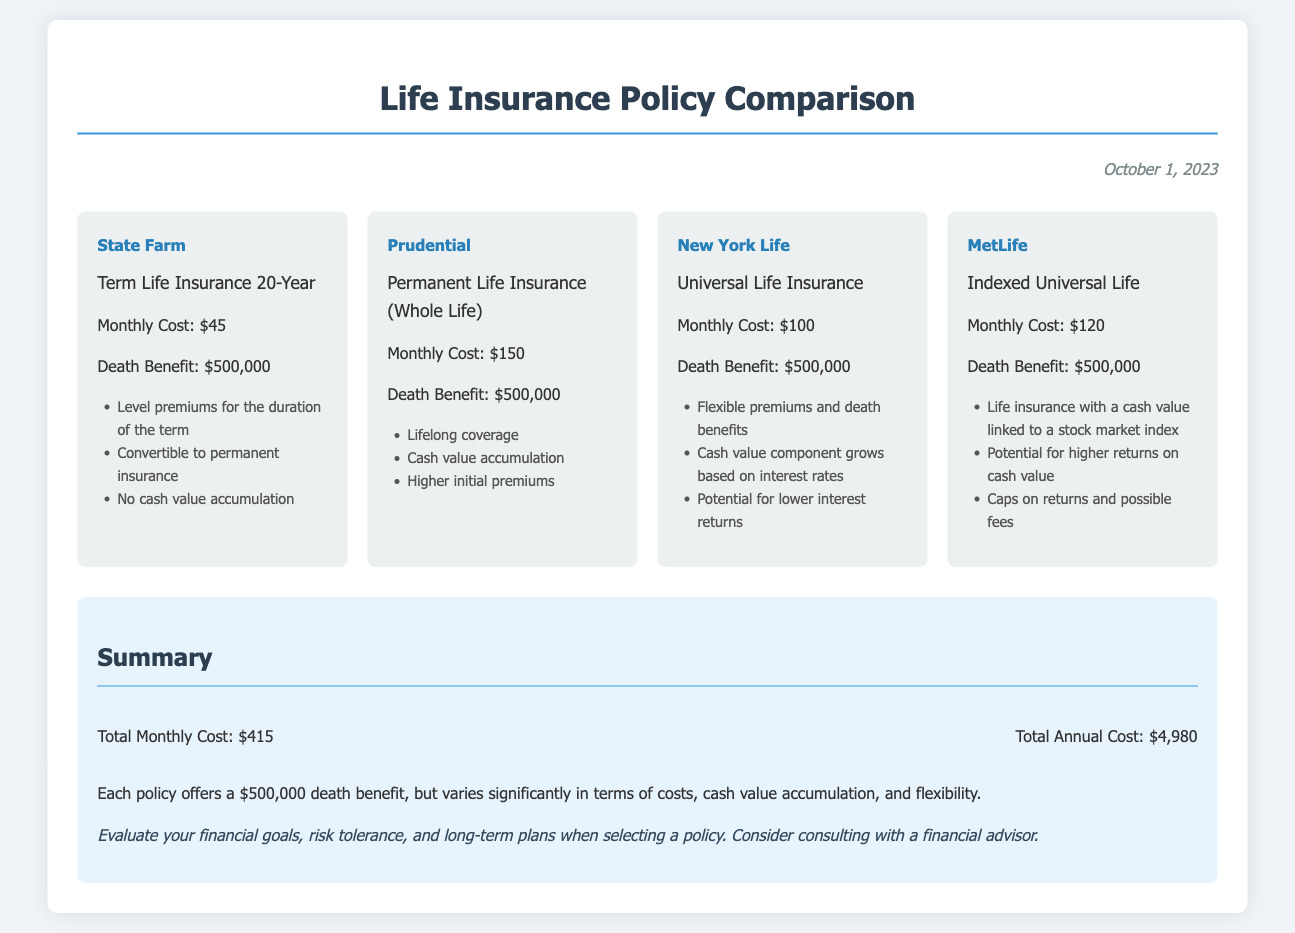What is the monthly cost for State Farm's policy? The monthly cost for State Farm's Term Life Insurance 20-Year policy is provided in the document, which is $45.
Answer: $45 What is the death benefit offered by Prudential? The document states that Prudential's policy offers a death benefit of $500,000.
Answer: $500,000 Which policy has the highest monthly cost? To determine the policy with the highest monthly cost, we compare the monthly costs provided in the document; Prudential has the highest at $150.
Answer: $150 What type of policy does New York Life offer? The document indicates that New York Life offers a Universal Life Insurance policy.
Answer: Universal Life Insurance What is the total annual cost for all policies? The document calculates the total annual cost by multiplying the total monthly cost of $415 by 12 months, leading to an annual total of $4,980.
Answer: $4,980 How many policies offer cash value accumulation? Cash value accumulation is mentioned for Prudential's Whole Life and New York Life's Universal Life policies, making it two policies.
Answer: 2 What is a key consideration for MetLife's Indexed Universal Life? The document lists one key consideration for this policy as having the cash value linked to a stock market index.
Answer: Linked to a stock market index Which policy allows for converting to permanent insurance? The information in the document specifies that State Farm's Term Life Insurance allows for convertible to permanent insurance.
Answer: Convertible to permanent insurance What recommendation is made regarding policy selection? The document recommends evaluating financial goals, risk tolerance, and possibly consulting with a financial advisor when selecting a policy.
Answer: Consult a financial advisor 